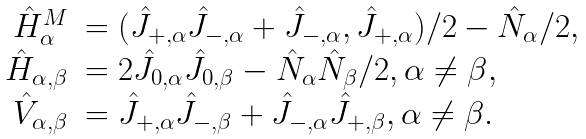Convert formula to latex. <formula><loc_0><loc_0><loc_500><loc_500>\begin{array} { r l } \hat { H } _ { \alpha } ^ { M } & = ( \hat { J } _ { + , \alpha } \hat { J } _ { - , \alpha } + \hat { J } _ { - , \alpha } , \hat { J } _ { + , \alpha } ) / 2 - \hat { N } _ { \alpha } / 2 , \\ \hat { H } _ { \alpha , \beta } & = 2 \hat { J } _ { 0 , \alpha } \hat { J } _ { 0 , \beta } - \hat { N } _ { \alpha } \hat { N } _ { \beta } / 2 , \alpha \neq \beta , \\ \hat { V } _ { \alpha , \beta } & = \hat { J } _ { + , \alpha } \hat { J } _ { - , \beta } + \hat { J } _ { - , \alpha } \hat { J } _ { + , \beta } , \alpha \neq \beta . \end{array}</formula> 